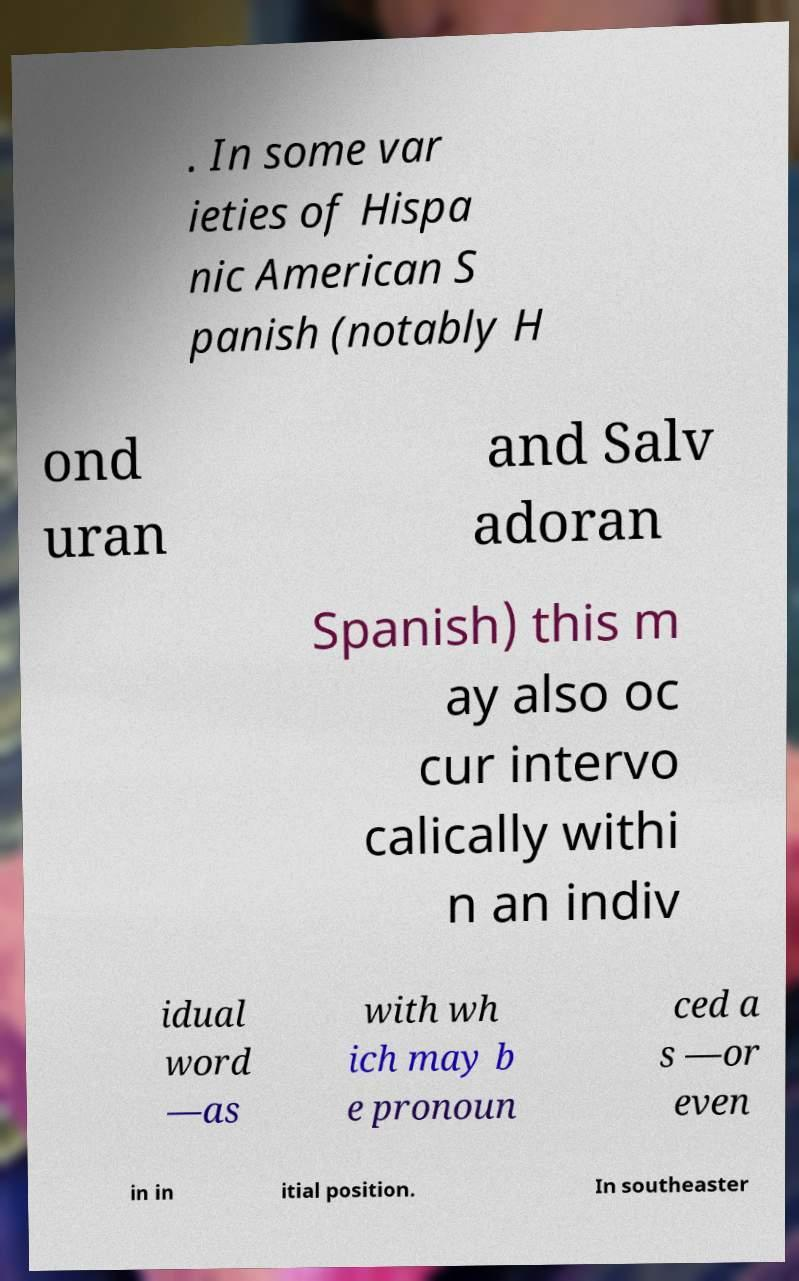Could you extract and type out the text from this image? . In some var ieties of Hispa nic American S panish (notably H ond uran and Salv adoran Spanish) this m ay also oc cur intervo calically withi n an indiv idual word —as with wh ich may b e pronoun ced a s —or even in in itial position. In southeaster 